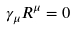<formula> <loc_0><loc_0><loc_500><loc_500>\gamma _ { \mu } R ^ { \mu } = 0</formula> 